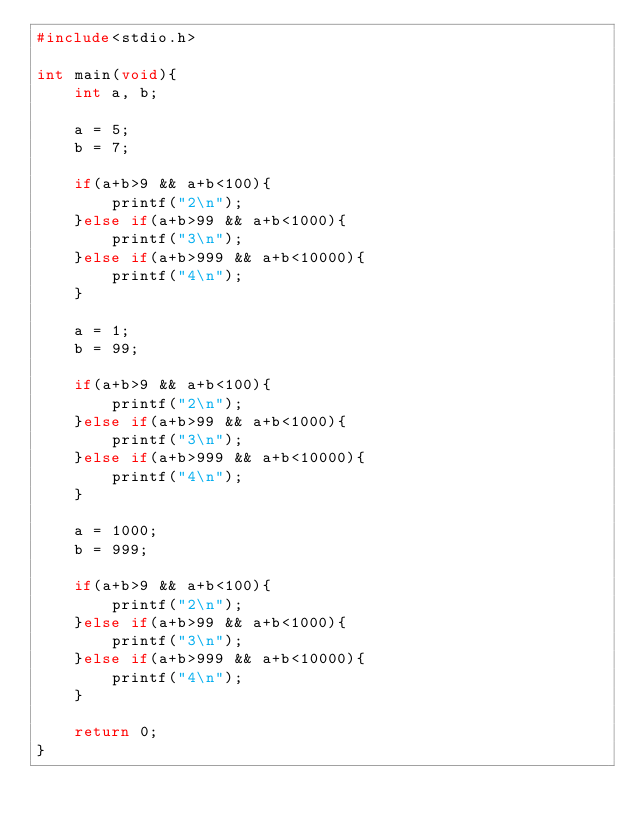<code> <loc_0><loc_0><loc_500><loc_500><_C_>#include<stdio.h>

int main(void){
	int a, b;
	
	a = 5;
	b = 7;
	
	if(a+b>9 && a+b<100){
		printf("2\n");
	}else if(a+b>99 && a+b<1000){
		printf("3\n");
	}else if(a+b>999 && a+b<10000){
		printf("4\n");
	}
	
	a = 1;
	b = 99;
	
	if(a+b>9 && a+b<100){
		printf("2\n");
	}else if(a+b>99 && a+b<1000){
		printf("3\n");
	}else if(a+b>999 && a+b<10000){
		printf("4\n");
	}
	
	a = 1000;
	b = 999;
	
	if(a+b>9 && a+b<100){
		printf("2\n");
	}else if(a+b>99 && a+b<1000){
		printf("3\n");
	}else if(a+b>999 && a+b<10000){
		printf("4\n");
	}
	
	return 0;
}
	</code> 